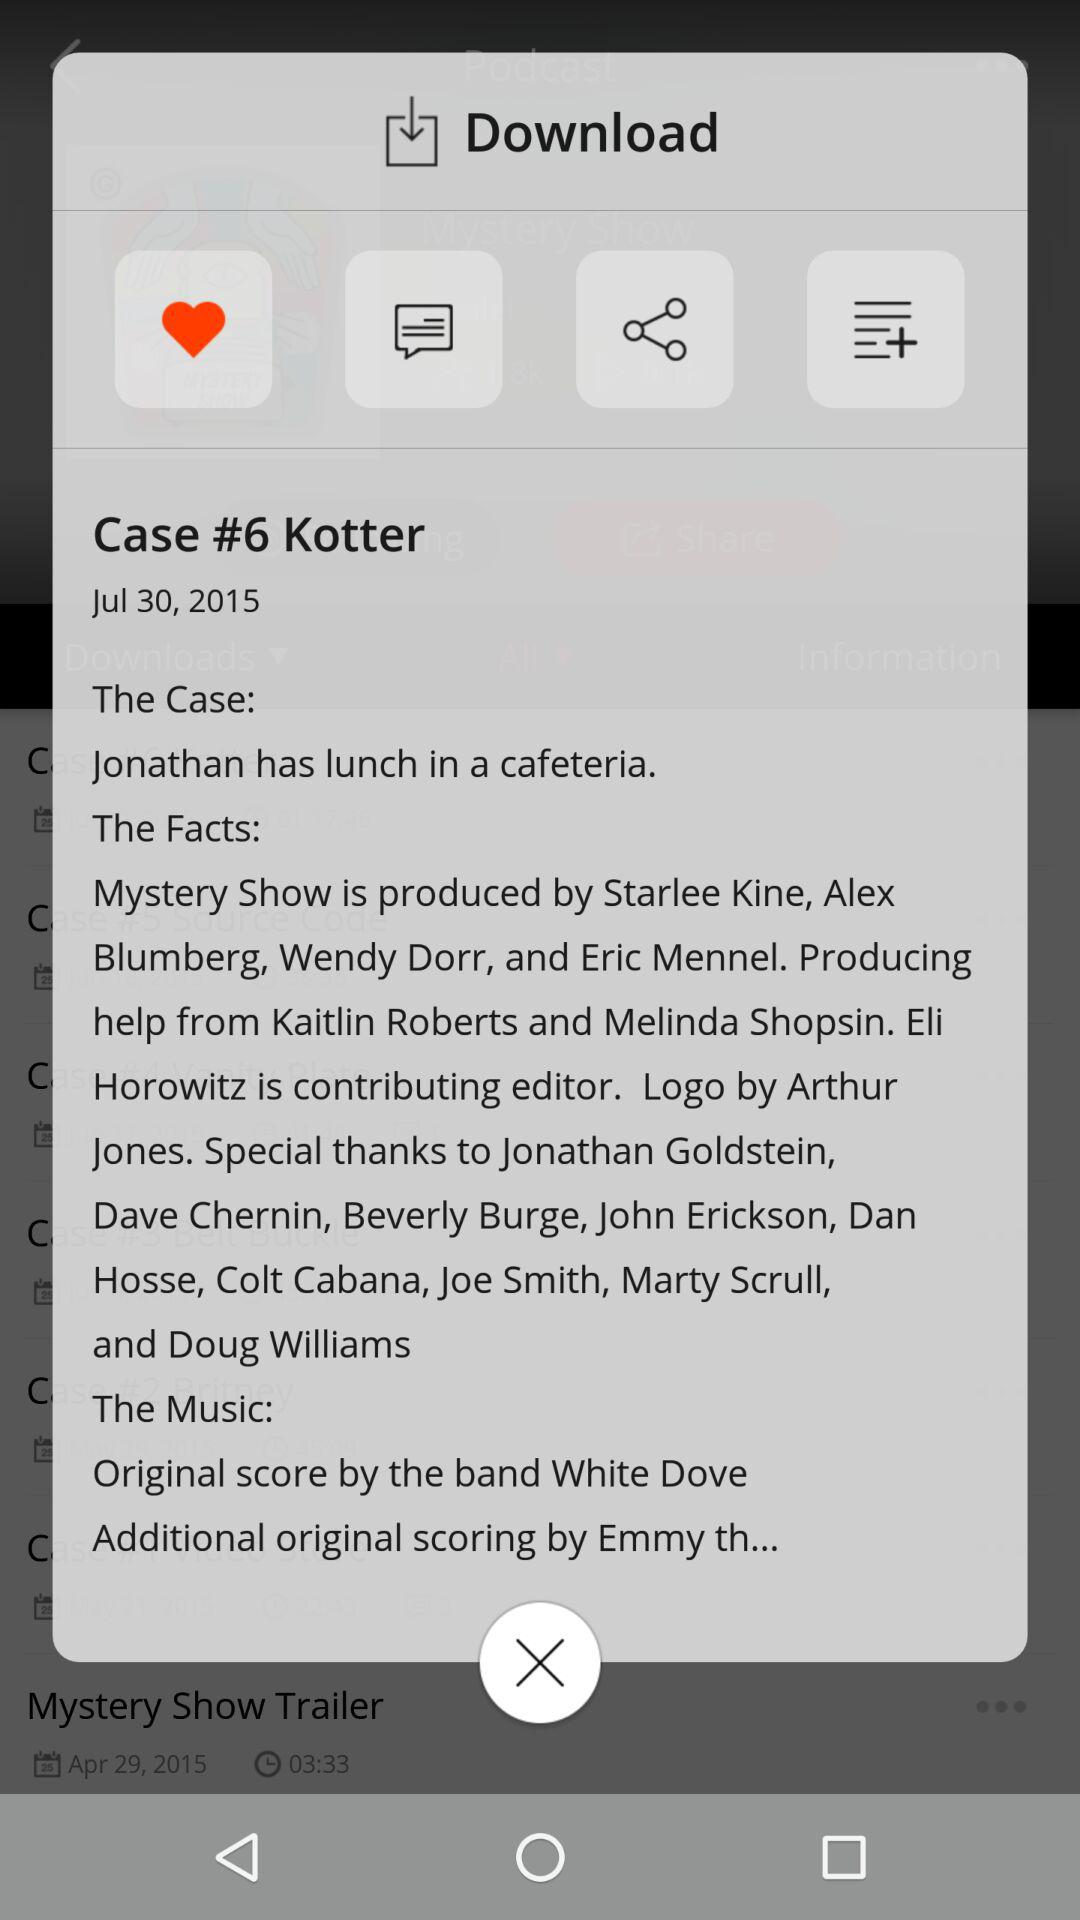Who ate lunch with Jonathan in a cafeteria?
When the provided information is insufficient, respond with <no answer>. <no answer> 